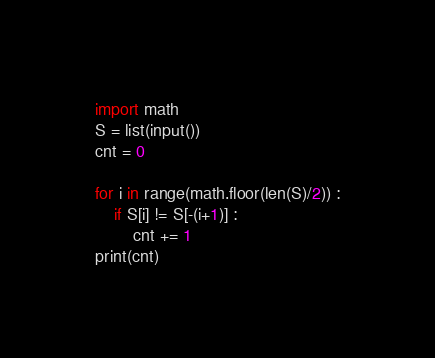<code> <loc_0><loc_0><loc_500><loc_500><_Python_>import math
S = list(input())
cnt = 0

for i in range(math.floor(len(S)/2)) :
    if S[i] != S[-(i+1)] :
        cnt += 1
print(cnt)</code> 